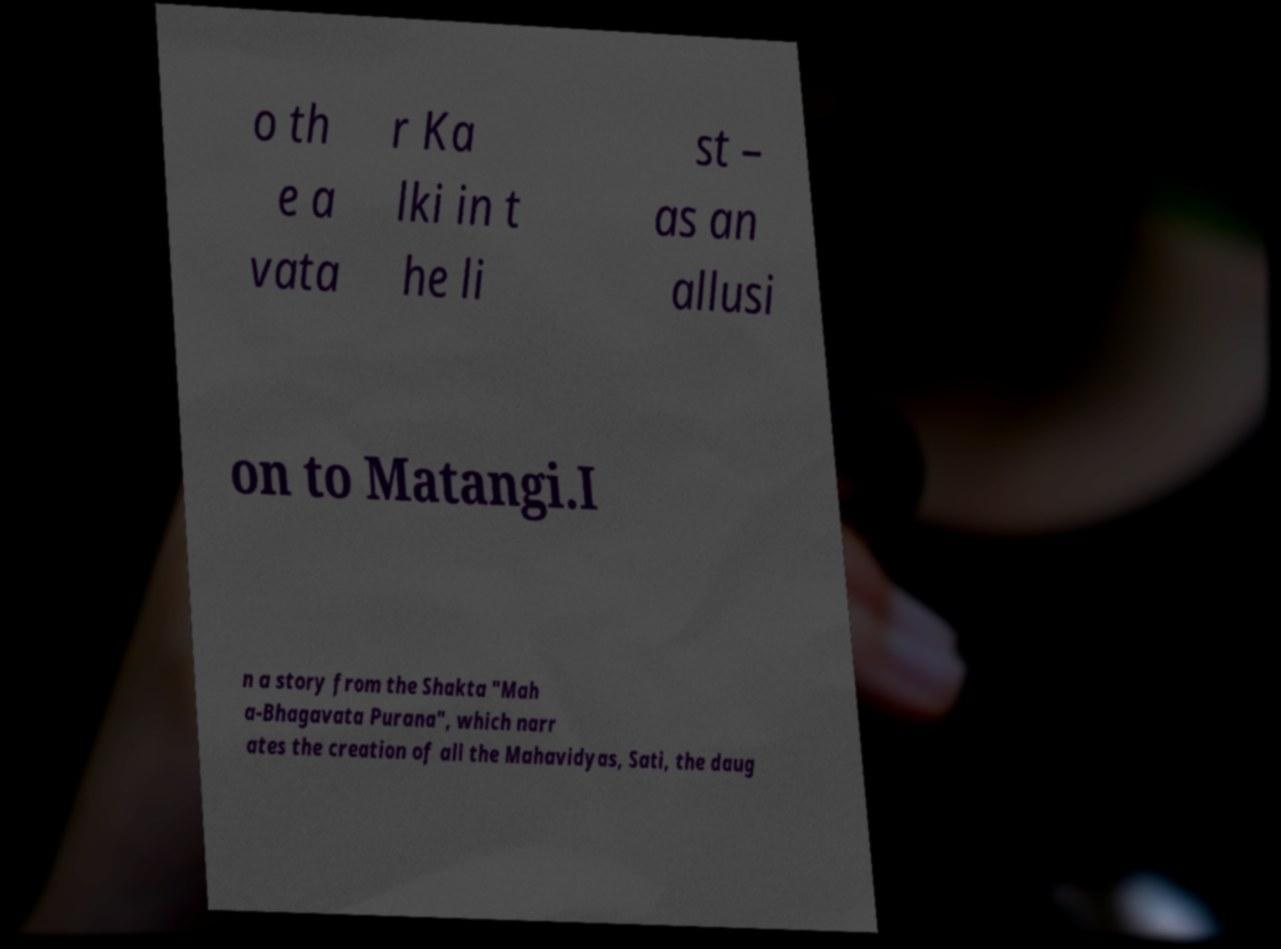Can you accurately transcribe the text from the provided image for me? o th e a vata r Ka lki in t he li st – as an allusi on to Matangi.I n a story from the Shakta "Mah a-Bhagavata Purana", which narr ates the creation of all the Mahavidyas, Sati, the daug 